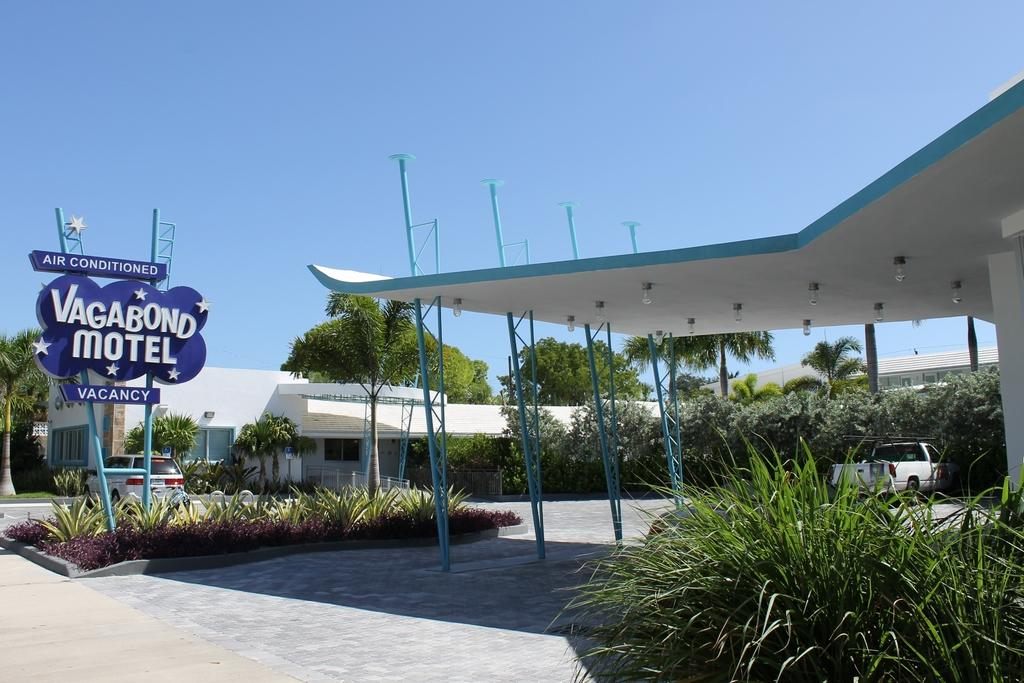<image>
Summarize the visual content of the image. Blue motel sign that has air conditioning written at the top in white letters. 